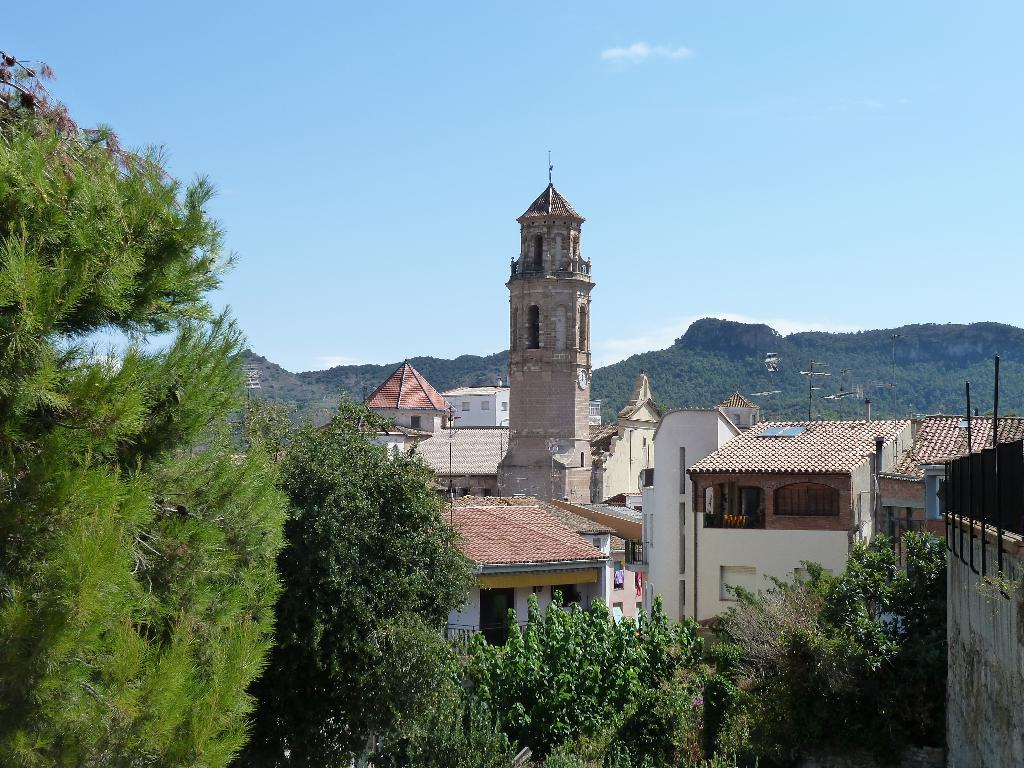What is the color of the sky in the image? The sky is blue in the image. What type of structures can be seen in the image? There are buildings with windows in the image. What type of vegetation is present in the image? There are trees in the image. What time is it according to the church clock in the image? There is no church or clock present in the image. What type of coil is used to support the trees in the image? There are no coils present in the image; the trees are standing on their own. 